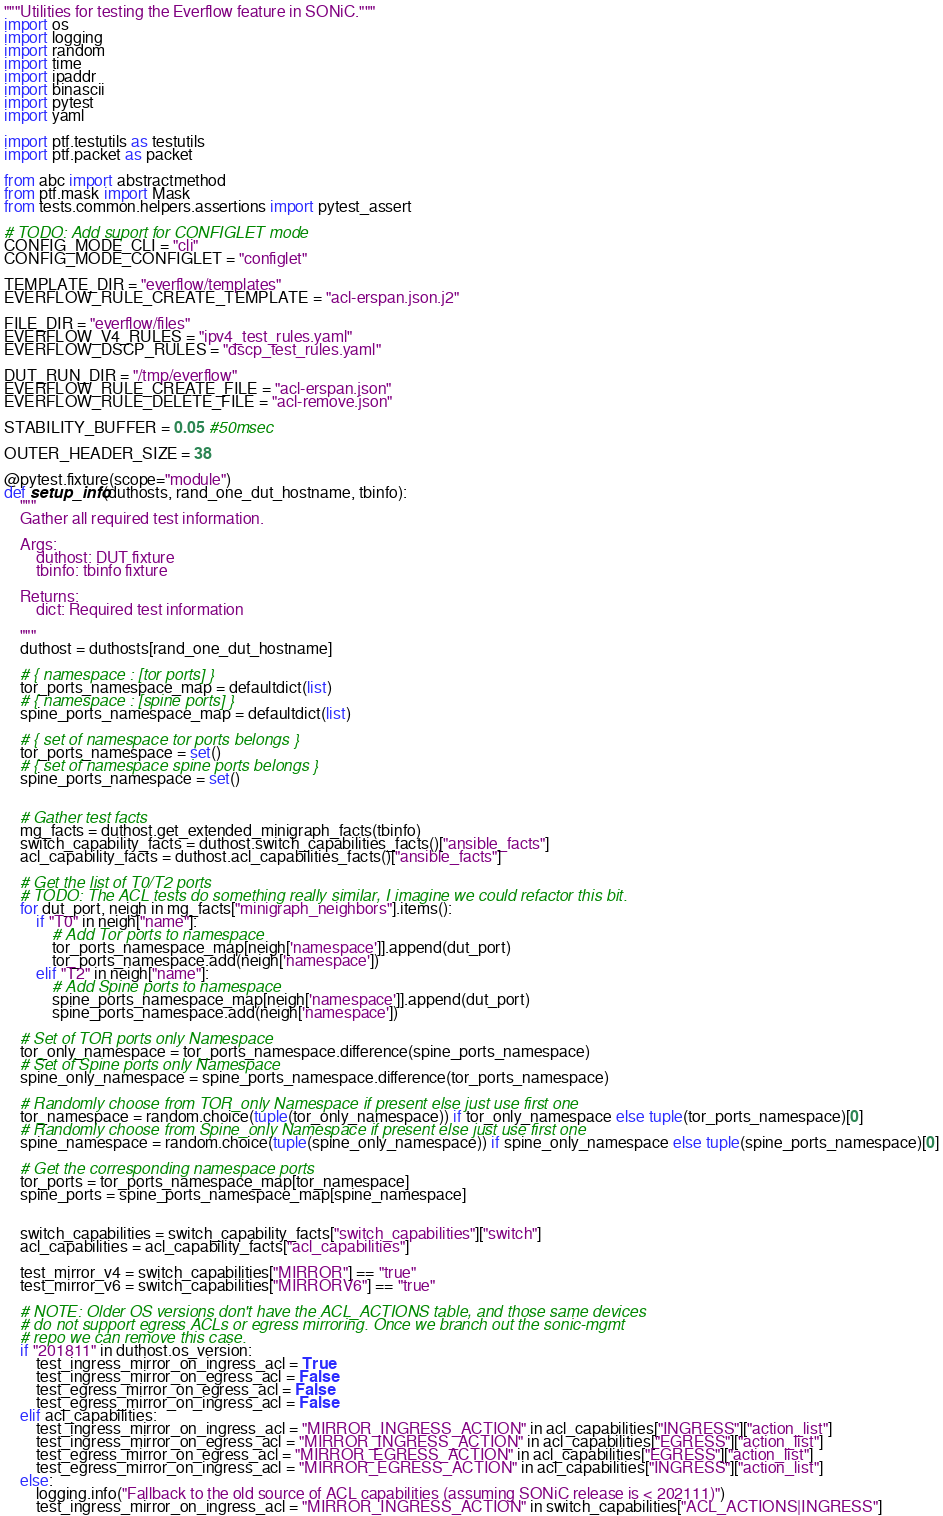Convert code to text. <code><loc_0><loc_0><loc_500><loc_500><_Python_>"""Utilities for testing the Everflow feature in SONiC."""
import os
import logging
import random
import time
import ipaddr
import binascii
import pytest
import yaml

import ptf.testutils as testutils
import ptf.packet as packet

from abc import abstractmethod
from ptf.mask import Mask
from tests.common.helpers.assertions import pytest_assert

# TODO: Add suport for CONFIGLET mode
CONFIG_MODE_CLI = "cli"
CONFIG_MODE_CONFIGLET = "configlet"

TEMPLATE_DIR = "everflow/templates"
EVERFLOW_RULE_CREATE_TEMPLATE = "acl-erspan.json.j2"

FILE_DIR = "everflow/files"
EVERFLOW_V4_RULES = "ipv4_test_rules.yaml"
EVERFLOW_DSCP_RULES = "dscp_test_rules.yaml"

DUT_RUN_DIR = "/tmp/everflow"
EVERFLOW_RULE_CREATE_FILE = "acl-erspan.json"
EVERFLOW_RULE_DELETE_FILE = "acl-remove.json"

STABILITY_BUFFER = 0.05 #50msec

OUTER_HEADER_SIZE = 38

@pytest.fixture(scope="module")
def setup_info(duthosts, rand_one_dut_hostname, tbinfo):
    """
    Gather all required test information.

    Args:
        duthost: DUT fixture
        tbinfo: tbinfo fixture

    Returns:
        dict: Required test information

    """
    duthost = duthosts[rand_one_dut_hostname]

    # { namespace : [tor ports] }
    tor_ports_namespace_map = defaultdict(list)
    # { namespace : [spine ports] }
    spine_ports_namespace_map = defaultdict(list)

    # { set of namespace tor ports belongs }
    tor_ports_namespace = set()
    # { set of namespace spine ports belongs }
    spine_ports_namespace = set()


    # Gather test facts
    mg_facts = duthost.get_extended_minigraph_facts(tbinfo)
    switch_capability_facts = duthost.switch_capabilities_facts()["ansible_facts"]
    acl_capability_facts = duthost.acl_capabilities_facts()["ansible_facts"]

    # Get the list of T0/T2 ports
    # TODO: The ACL tests do something really similar, I imagine we could refactor this bit.
    for dut_port, neigh in mg_facts["minigraph_neighbors"].items():
        if "T0" in neigh["name"]:
            # Add Tor ports to namespace
            tor_ports_namespace_map[neigh['namespace']].append(dut_port)
            tor_ports_namespace.add(neigh['namespace'])
        elif "T2" in neigh["name"]:
            # Add Spine ports to namespace
            spine_ports_namespace_map[neigh['namespace']].append(dut_port)
            spine_ports_namespace.add(neigh['namespace'])

    # Set of TOR ports only Namespace
    tor_only_namespace = tor_ports_namespace.difference(spine_ports_namespace)
    # Set of Spine ports only Namespace
    spine_only_namespace = spine_ports_namespace.difference(tor_ports_namespace)

    # Randomly choose from TOR_only Namespace if present else just use first one
    tor_namespace = random.choice(tuple(tor_only_namespace)) if tor_only_namespace else tuple(tor_ports_namespace)[0]
    # Randomly choose from Spine_only Namespace if present else just use first one
    spine_namespace = random.choice(tuple(spine_only_namespace)) if spine_only_namespace else tuple(spine_ports_namespace)[0]

    # Get the corresponding namespace ports
    tor_ports = tor_ports_namespace_map[tor_namespace]
    spine_ports = spine_ports_namespace_map[spine_namespace]


    switch_capabilities = switch_capability_facts["switch_capabilities"]["switch"]
    acl_capabilities = acl_capability_facts["acl_capabilities"]

    test_mirror_v4 = switch_capabilities["MIRROR"] == "true"
    test_mirror_v6 = switch_capabilities["MIRRORV6"] == "true"

    # NOTE: Older OS versions don't have the ACL_ACTIONS table, and those same devices
    # do not support egress ACLs or egress mirroring. Once we branch out the sonic-mgmt
    # repo we can remove this case.
    if "201811" in duthost.os_version:
        test_ingress_mirror_on_ingress_acl = True
        test_ingress_mirror_on_egress_acl = False
        test_egress_mirror_on_egress_acl = False
        test_egress_mirror_on_ingress_acl = False
    elif acl_capabilities:
        test_ingress_mirror_on_ingress_acl = "MIRROR_INGRESS_ACTION" in acl_capabilities["INGRESS"]["action_list"]
        test_ingress_mirror_on_egress_acl = "MIRROR_INGRESS_ACTION" in acl_capabilities["EGRESS"]["action_list"]
        test_egress_mirror_on_egress_acl = "MIRROR_EGRESS_ACTION" in acl_capabilities["EGRESS"]["action_list"]
        test_egress_mirror_on_ingress_acl = "MIRROR_EGRESS_ACTION" in acl_capabilities["INGRESS"]["action_list"]
    else:
        logging.info("Fallback to the old source of ACL capabilities (assuming SONiC release is < 202111)")
        test_ingress_mirror_on_ingress_acl = "MIRROR_INGRESS_ACTION" in switch_capabilities["ACL_ACTIONS|INGRESS"]</code> 